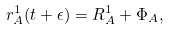Convert formula to latex. <formula><loc_0><loc_0><loc_500><loc_500>r ^ { 1 } _ { A } ( t + \epsilon ) = R ^ { 1 } _ { A } + \Phi _ { A } ,</formula> 